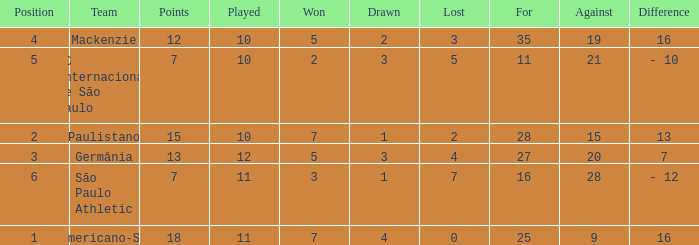Could you help me parse every detail presented in this table? {'header': ['Position', 'Team', 'Points', 'Played', 'Won', 'Drawn', 'Lost', 'For', 'Against', 'Difference'], 'rows': [['4', 'Mackenzie', '12', '10', '5', '2', '3', '35', '19', '16'], ['5', 'SC Internacional de São Paulo', '7', '10', '2', '3', '5', '11', '21', '- 10'], ['2', 'Paulistano', '15', '10', '7', '1', '2', '28', '15', '13'], ['3', 'Germânia', '13', '12', '5', '3', '4', '27', '20', '7'], ['6', 'São Paulo Athletic', '7', '11', '3', '1', '7', '16', '28', '- 12'], ['1', 'Americano-SP', '18', '11', '7', '4', '0', '25', '9', '16']]} Name the least for when played is 12 27.0. 